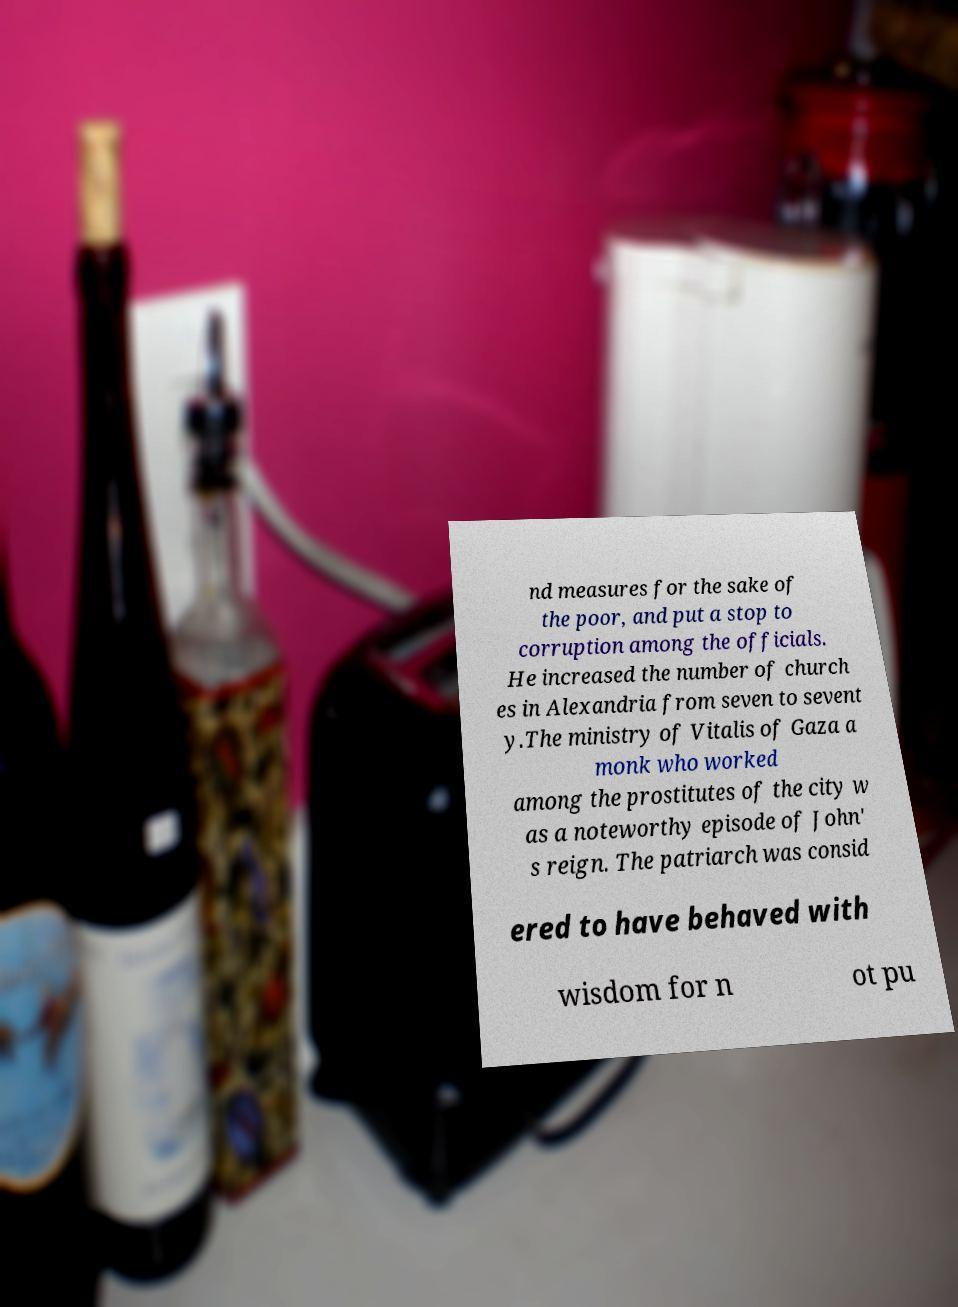Please read and relay the text visible in this image. What does it say? nd measures for the sake of the poor, and put a stop to corruption among the officials. He increased the number of church es in Alexandria from seven to sevent y.The ministry of Vitalis of Gaza a monk who worked among the prostitutes of the city w as a noteworthy episode of John' s reign. The patriarch was consid ered to have behaved with wisdom for n ot pu 